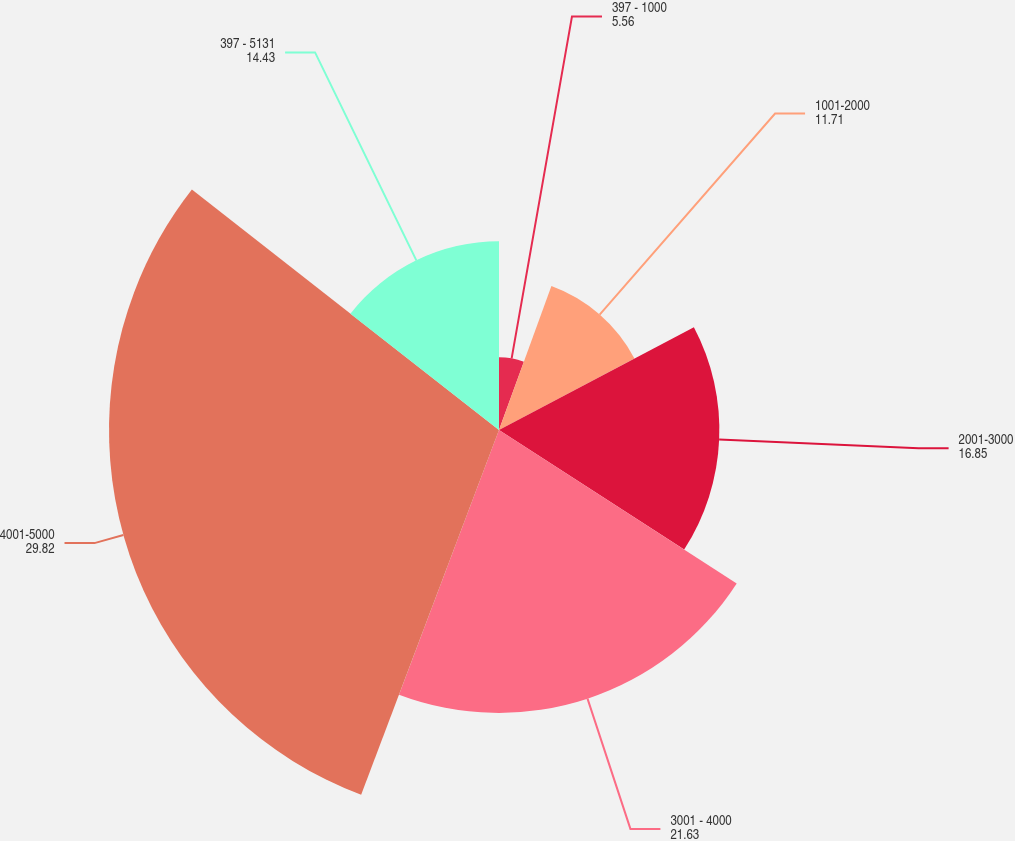Convert chart to OTSL. <chart><loc_0><loc_0><loc_500><loc_500><pie_chart><fcel>397 - 1000<fcel>1001-2000<fcel>2001-3000<fcel>3001 - 4000<fcel>4001-5000<fcel>397 - 5131<nl><fcel>5.56%<fcel>11.71%<fcel>16.85%<fcel>21.63%<fcel>29.82%<fcel>14.43%<nl></chart> 